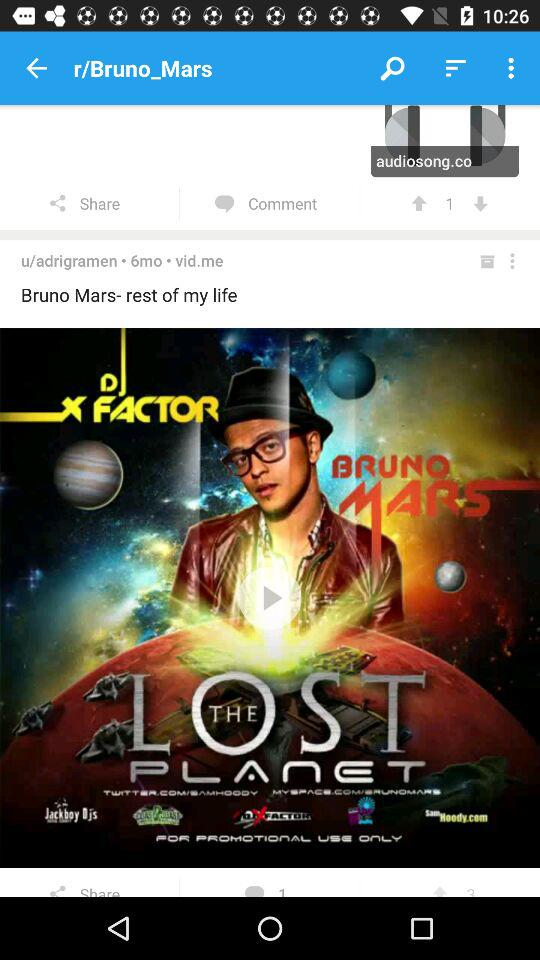What's the name of the movie? The name of the movie is "Bruno Mars- rest of my life". 